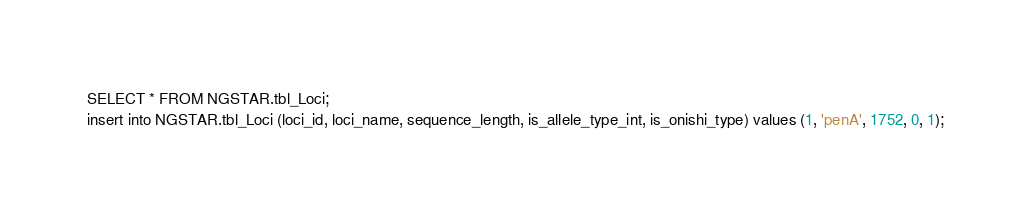<code> <loc_0><loc_0><loc_500><loc_500><_SQL_>SELECT * FROM NGSTAR.tbl_Loci;
insert into NGSTAR.tbl_Loci (loci_id, loci_name, sequence_length, is_allele_type_int, is_onishi_type) values (1, 'penA', 1752, 0, 1);</code> 